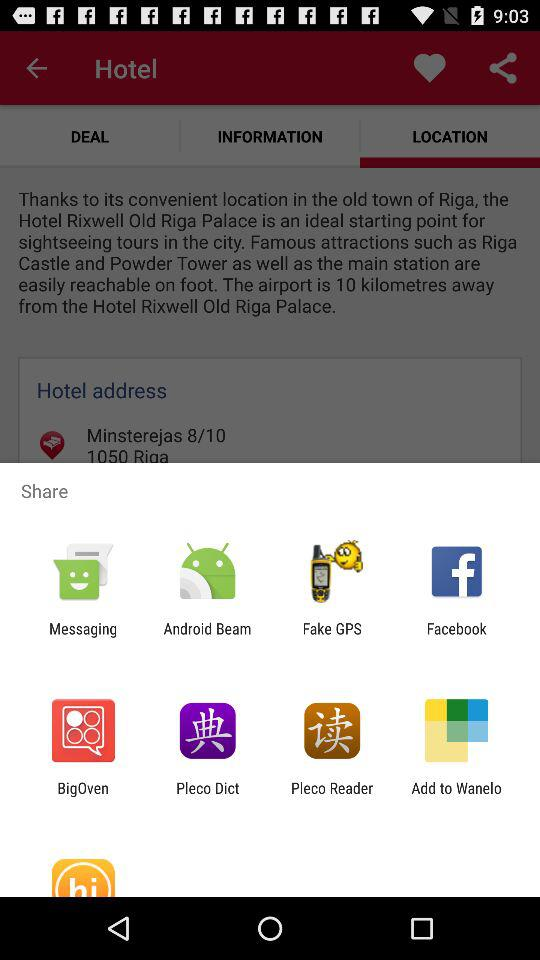What apps can be used to share the location of the hotel? The apps that can be used are "Messaging", "Android Beam", "Fake GPS", "Facebook", "BigOven", "Pleco Dict", "Pleco Reader", and "Add to Wanelo". 